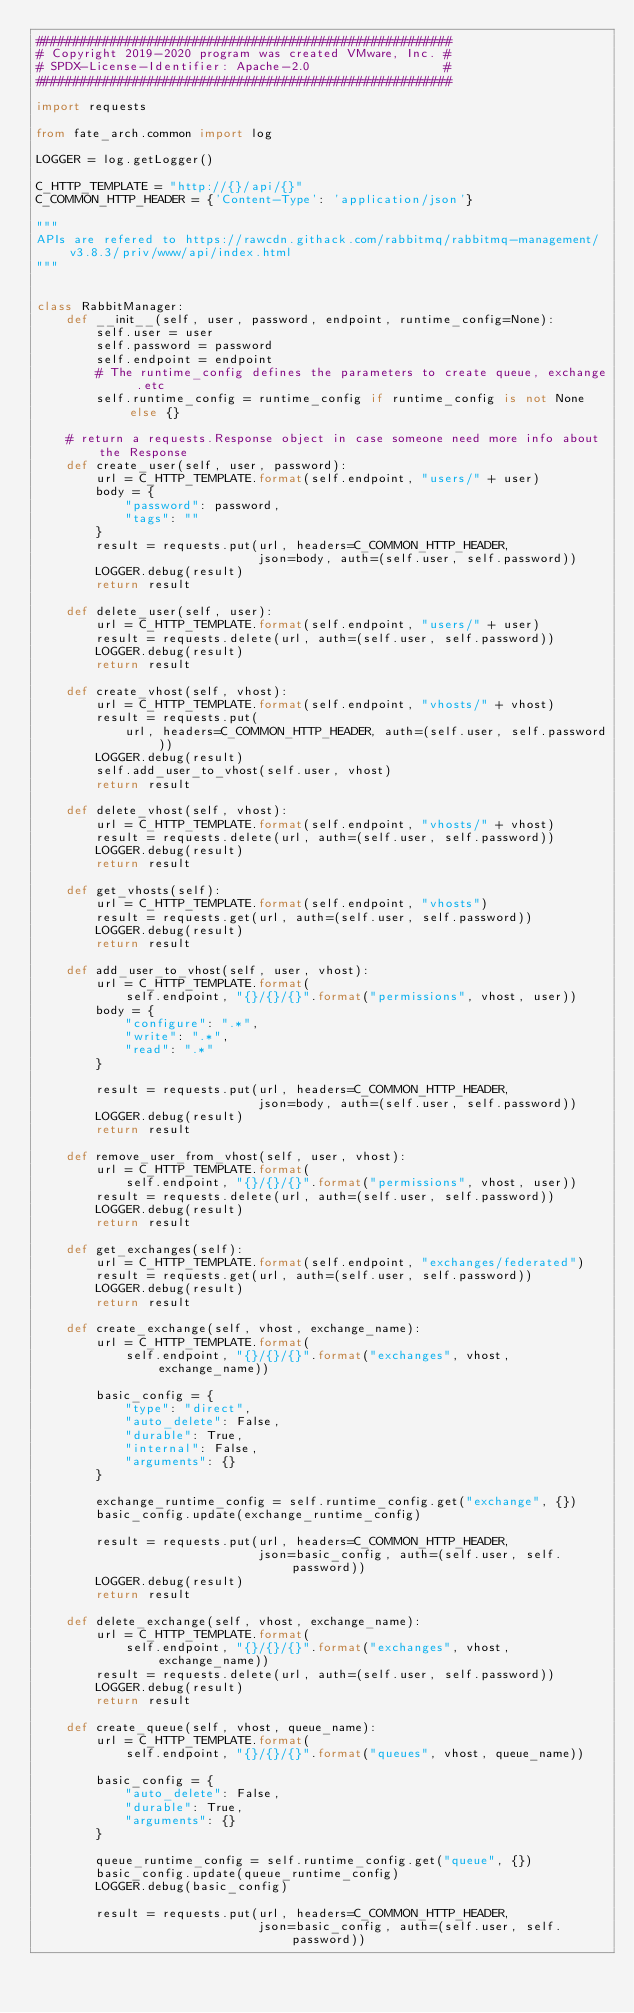<code> <loc_0><loc_0><loc_500><loc_500><_Python_>########################################################
# Copyright 2019-2020 program was created VMware, Inc. #
# SPDX-License-Identifier: Apache-2.0                  #
########################################################

import requests

from fate_arch.common import log

LOGGER = log.getLogger()

C_HTTP_TEMPLATE = "http://{}/api/{}"
C_COMMON_HTTP_HEADER = {'Content-Type': 'application/json'}

"""
APIs are refered to https://rawcdn.githack.com/rabbitmq/rabbitmq-management/v3.8.3/priv/www/api/index.html
"""


class RabbitManager:
    def __init__(self, user, password, endpoint, runtime_config=None):
        self.user = user
        self.password = password
        self.endpoint = endpoint
        # The runtime_config defines the parameters to create queue, exchange .etc
        self.runtime_config = runtime_config if runtime_config is not None else {}

    # return a requests.Response object in case someone need more info about the Response
    def create_user(self, user, password):
        url = C_HTTP_TEMPLATE.format(self.endpoint, "users/" + user)
        body = {
            "password": password,
            "tags": ""
        }
        result = requests.put(url, headers=C_COMMON_HTTP_HEADER,
                              json=body, auth=(self.user, self.password))
        LOGGER.debug(result)
        return result

    def delete_user(self, user):
        url = C_HTTP_TEMPLATE.format(self.endpoint, "users/" + user)
        result = requests.delete(url, auth=(self.user, self.password))
        LOGGER.debug(result)
        return result

    def create_vhost(self, vhost):
        url = C_HTTP_TEMPLATE.format(self.endpoint, "vhosts/" + vhost)
        result = requests.put(
            url, headers=C_COMMON_HTTP_HEADER, auth=(self.user, self.password))
        LOGGER.debug(result)
        self.add_user_to_vhost(self.user, vhost)
        return result

    def delete_vhost(self, vhost):
        url = C_HTTP_TEMPLATE.format(self.endpoint, "vhosts/" + vhost)
        result = requests.delete(url, auth=(self.user, self.password))
        LOGGER.debug(result)
        return result

    def get_vhosts(self):
        url = C_HTTP_TEMPLATE.format(self.endpoint, "vhosts")
        result = requests.get(url, auth=(self.user, self.password))
        LOGGER.debug(result)
        return result

    def add_user_to_vhost(self, user, vhost):
        url = C_HTTP_TEMPLATE.format(
            self.endpoint, "{}/{}/{}".format("permissions", vhost, user))
        body = {
            "configure": ".*",
            "write": ".*",
            "read": ".*"
        }

        result = requests.put(url, headers=C_COMMON_HTTP_HEADER,
                              json=body, auth=(self.user, self.password))
        LOGGER.debug(result)
        return result

    def remove_user_from_vhost(self, user, vhost):
        url = C_HTTP_TEMPLATE.format(
            self.endpoint, "{}/{}/{}".format("permissions", vhost, user))
        result = requests.delete(url, auth=(self.user, self.password))
        LOGGER.debug(result)
        return result

    def get_exchanges(self):
        url = C_HTTP_TEMPLATE.format(self.endpoint, "exchanges/federated")
        result = requests.get(url, auth=(self.user, self.password))
        LOGGER.debug(result)
        return result

    def create_exchange(self, vhost, exchange_name):
        url = C_HTTP_TEMPLATE.format(
            self.endpoint, "{}/{}/{}".format("exchanges", vhost, exchange_name))

        basic_config = {
            "type": "direct",
            "auto_delete": False,
            "durable": True,
            "internal": False,
            "arguments": {}
        }

        exchange_runtime_config = self.runtime_config.get("exchange", {})
        basic_config.update(exchange_runtime_config)

        result = requests.put(url, headers=C_COMMON_HTTP_HEADER,
                              json=basic_config, auth=(self.user, self.password))
        LOGGER.debug(result)
        return result

    def delete_exchange(self, vhost, exchange_name):
        url = C_HTTP_TEMPLATE.format(
            self.endpoint, "{}/{}/{}".format("exchanges", vhost, exchange_name))
        result = requests.delete(url, auth=(self.user, self.password))
        LOGGER.debug(result)
        return result

    def create_queue(self, vhost, queue_name):
        url = C_HTTP_TEMPLATE.format(
            self.endpoint, "{}/{}/{}".format("queues", vhost, queue_name))

        basic_config = {
            "auto_delete": False,
            "durable": True,
            "arguments": {}
        }

        queue_runtime_config = self.runtime_config.get("queue", {})
        basic_config.update(queue_runtime_config)
        LOGGER.debug(basic_config)

        result = requests.put(url, headers=C_COMMON_HTTP_HEADER,
                              json=basic_config, auth=(self.user, self.password))</code> 